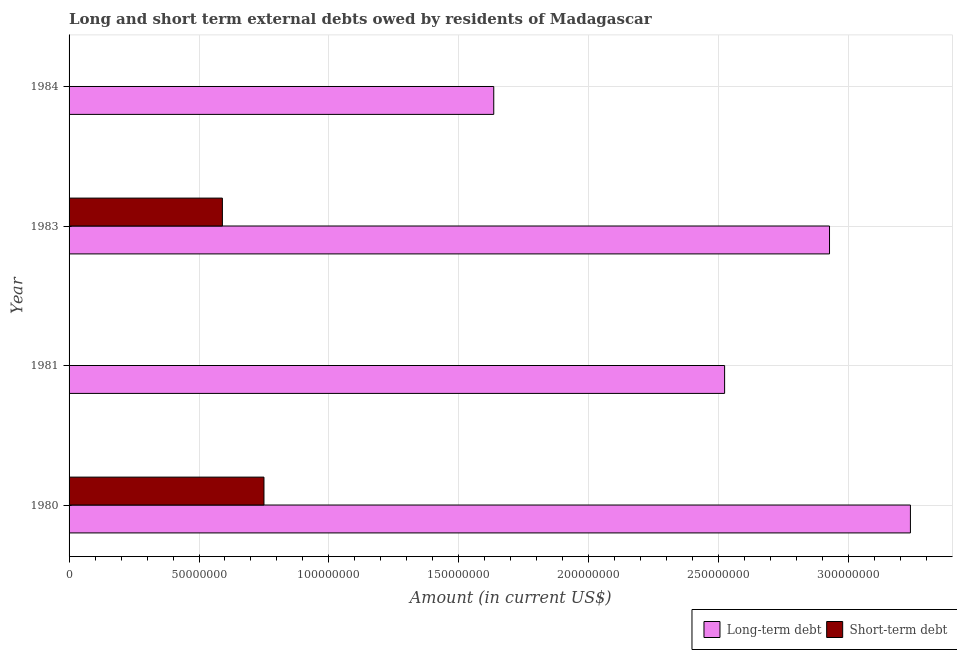How many different coloured bars are there?
Your response must be concise. 2. Are the number of bars on each tick of the Y-axis equal?
Provide a short and direct response. No. How many bars are there on the 3rd tick from the bottom?
Provide a succinct answer. 2. In how many cases, is the number of bars for a given year not equal to the number of legend labels?
Give a very brief answer. 2. What is the short-term debts owed by residents in 1980?
Provide a succinct answer. 7.50e+07. Across all years, what is the maximum short-term debts owed by residents?
Offer a terse response. 7.50e+07. What is the total short-term debts owed by residents in the graph?
Provide a succinct answer. 1.34e+08. What is the difference between the long-term debts owed by residents in 1980 and that in 1983?
Keep it short and to the point. 3.11e+07. What is the difference between the short-term debts owed by residents in 1980 and the long-term debts owed by residents in 1983?
Your response must be concise. -2.18e+08. What is the average long-term debts owed by residents per year?
Make the answer very short. 2.58e+08. In the year 1980, what is the difference between the short-term debts owed by residents and long-term debts owed by residents?
Give a very brief answer. -2.49e+08. What is the ratio of the long-term debts owed by residents in 1981 to that in 1983?
Give a very brief answer. 0.86. Is the long-term debts owed by residents in 1980 less than that in 1981?
Your answer should be compact. No. Is the difference between the short-term debts owed by residents in 1980 and 1983 greater than the difference between the long-term debts owed by residents in 1980 and 1983?
Provide a succinct answer. No. What is the difference between the highest and the lowest long-term debts owed by residents?
Give a very brief answer. 1.60e+08. In how many years, is the short-term debts owed by residents greater than the average short-term debts owed by residents taken over all years?
Provide a short and direct response. 2. How many bars are there?
Offer a very short reply. 6. Are all the bars in the graph horizontal?
Provide a short and direct response. Yes. How many years are there in the graph?
Provide a short and direct response. 4. What is the difference between two consecutive major ticks on the X-axis?
Offer a terse response. 5.00e+07. Does the graph contain any zero values?
Provide a short and direct response. Yes. Does the graph contain grids?
Ensure brevity in your answer.  Yes. How many legend labels are there?
Your response must be concise. 2. How are the legend labels stacked?
Provide a succinct answer. Horizontal. What is the title of the graph?
Your answer should be compact. Long and short term external debts owed by residents of Madagascar. What is the label or title of the X-axis?
Give a very brief answer. Amount (in current US$). What is the label or title of the Y-axis?
Offer a terse response. Year. What is the Amount (in current US$) of Long-term debt in 1980?
Offer a very short reply. 3.24e+08. What is the Amount (in current US$) in Short-term debt in 1980?
Make the answer very short. 7.50e+07. What is the Amount (in current US$) of Long-term debt in 1981?
Give a very brief answer. 2.52e+08. What is the Amount (in current US$) in Short-term debt in 1981?
Your response must be concise. 0. What is the Amount (in current US$) of Long-term debt in 1983?
Your answer should be compact. 2.93e+08. What is the Amount (in current US$) in Short-term debt in 1983?
Your answer should be very brief. 5.90e+07. What is the Amount (in current US$) of Long-term debt in 1984?
Offer a very short reply. 1.63e+08. Across all years, what is the maximum Amount (in current US$) in Long-term debt?
Make the answer very short. 3.24e+08. Across all years, what is the maximum Amount (in current US$) in Short-term debt?
Ensure brevity in your answer.  7.50e+07. Across all years, what is the minimum Amount (in current US$) in Long-term debt?
Give a very brief answer. 1.63e+08. What is the total Amount (in current US$) in Long-term debt in the graph?
Your response must be concise. 1.03e+09. What is the total Amount (in current US$) in Short-term debt in the graph?
Give a very brief answer. 1.34e+08. What is the difference between the Amount (in current US$) of Long-term debt in 1980 and that in 1981?
Offer a very short reply. 7.15e+07. What is the difference between the Amount (in current US$) in Long-term debt in 1980 and that in 1983?
Offer a terse response. 3.11e+07. What is the difference between the Amount (in current US$) in Short-term debt in 1980 and that in 1983?
Your response must be concise. 1.60e+07. What is the difference between the Amount (in current US$) in Long-term debt in 1980 and that in 1984?
Offer a terse response. 1.60e+08. What is the difference between the Amount (in current US$) of Long-term debt in 1981 and that in 1983?
Provide a succinct answer. -4.04e+07. What is the difference between the Amount (in current US$) in Long-term debt in 1981 and that in 1984?
Make the answer very short. 8.88e+07. What is the difference between the Amount (in current US$) in Long-term debt in 1983 and that in 1984?
Provide a succinct answer. 1.29e+08. What is the difference between the Amount (in current US$) of Long-term debt in 1980 and the Amount (in current US$) of Short-term debt in 1983?
Ensure brevity in your answer.  2.65e+08. What is the difference between the Amount (in current US$) in Long-term debt in 1981 and the Amount (in current US$) in Short-term debt in 1983?
Your answer should be very brief. 1.93e+08. What is the average Amount (in current US$) in Long-term debt per year?
Ensure brevity in your answer.  2.58e+08. What is the average Amount (in current US$) in Short-term debt per year?
Provide a succinct answer. 3.35e+07. In the year 1980, what is the difference between the Amount (in current US$) of Long-term debt and Amount (in current US$) of Short-term debt?
Ensure brevity in your answer.  2.49e+08. In the year 1983, what is the difference between the Amount (in current US$) of Long-term debt and Amount (in current US$) of Short-term debt?
Provide a short and direct response. 2.34e+08. What is the ratio of the Amount (in current US$) in Long-term debt in 1980 to that in 1981?
Provide a succinct answer. 1.28. What is the ratio of the Amount (in current US$) of Long-term debt in 1980 to that in 1983?
Offer a very short reply. 1.11. What is the ratio of the Amount (in current US$) of Short-term debt in 1980 to that in 1983?
Your answer should be very brief. 1.27. What is the ratio of the Amount (in current US$) in Long-term debt in 1980 to that in 1984?
Keep it short and to the point. 1.98. What is the ratio of the Amount (in current US$) in Long-term debt in 1981 to that in 1983?
Your answer should be compact. 0.86. What is the ratio of the Amount (in current US$) of Long-term debt in 1981 to that in 1984?
Provide a succinct answer. 1.54. What is the ratio of the Amount (in current US$) in Long-term debt in 1983 to that in 1984?
Make the answer very short. 1.79. What is the difference between the highest and the second highest Amount (in current US$) in Long-term debt?
Your answer should be compact. 3.11e+07. What is the difference between the highest and the lowest Amount (in current US$) of Long-term debt?
Your response must be concise. 1.60e+08. What is the difference between the highest and the lowest Amount (in current US$) in Short-term debt?
Make the answer very short. 7.50e+07. 